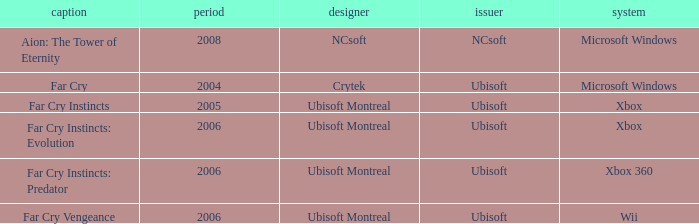Which title has xbox as the platform with a year prior to 2006? Far Cry Instincts. 